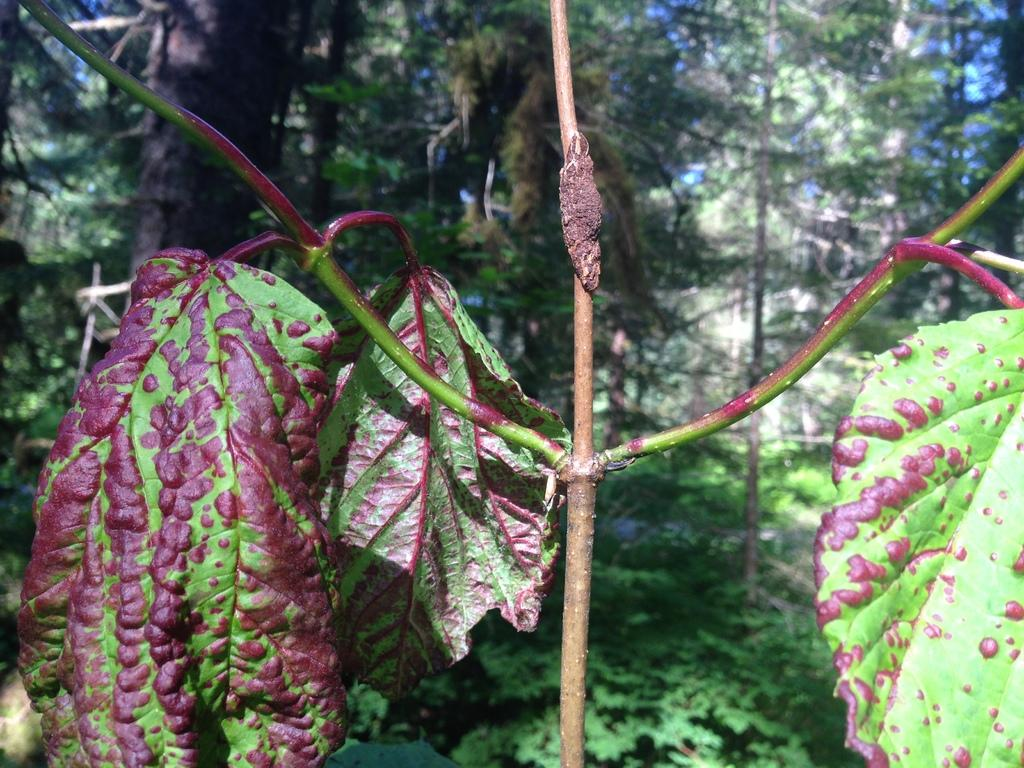What is the main subject in the center of the image? There is a plant with branches and leaves in the center of the image. What can be seen in the background of the image? There are trees visible in the background of the image. What type of feeling does the rat in the image have? There is no rat present in the image, so it is not possible to determine any feelings it might have. 